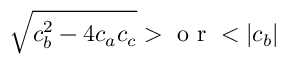Convert formula to latex. <formula><loc_0><loc_0><loc_500><loc_500>\sqrt { c _ { b } ^ { 2 } - 4 c _ { a } c _ { c } } > o r < | c _ { b } |</formula> 